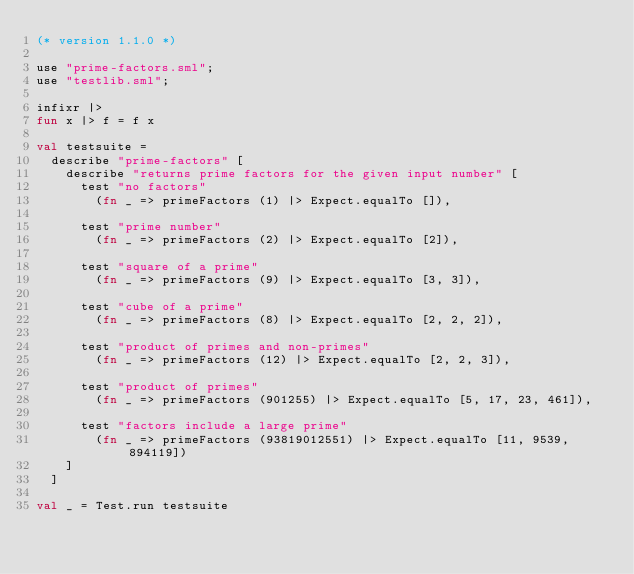<code> <loc_0><loc_0><loc_500><loc_500><_SML_>(* version 1.1.0 *)

use "prime-factors.sml";
use "testlib.sml";

infixr |>
fun x |> f = f x

val testsuite =
  describe "prime-factors" [
    describe "returns prime factors for the given input number" [
      test "no factors"
        (fn _ => primeFactors (1) |> Expect.equalTo []),

      test "prime number"
        (fn _ => primeFactors (2) |> Expect.equalTo [2]),

      test "square of a prime"
        (fn _ => primeFactors (9) |> Expect.equalTo [3, 3]),

      test "cube of a prime"
        (fn _ => primeFactors (8) |> Expect.equalTo [2, 2, 2]),

      test "product of primes and non-primes"
        (fn _ => primeFactors (12) |> Expect.equalTo [2, 2, 3]),

      test "product of primes"
        (fn _ => primeFactors (901255) |> Expect.equalTo [5, 17, 23, 461]),

      test "factors include a large prime"
        (fn _ => primeFactors (93819012551) |> Expect.equalTo [11, 9539, 894119])
    ]
  ]

val _ = Test.run testsuite</code> 